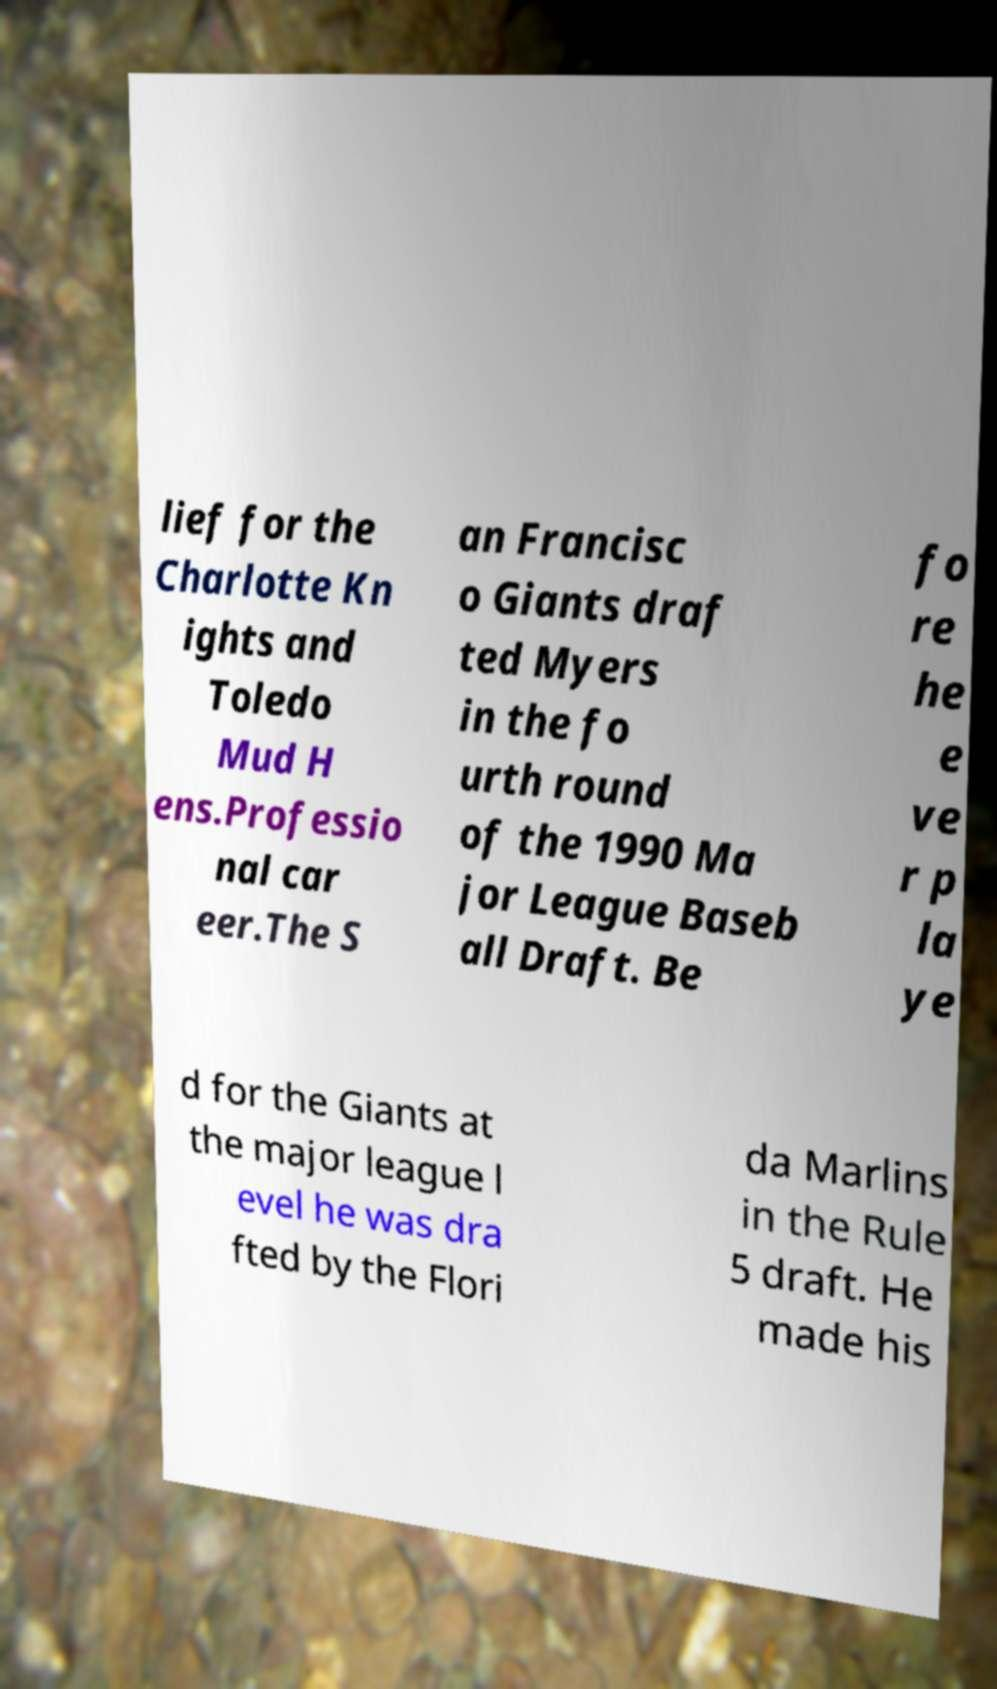What messages or text are displayed in this image? I need them in a readable, typed format. lief for the Charlotte Kn ights and Toledo Mud H ens.Professio nal car eer.The S an Francisc o Giants draf ted Myers in the fo urth round of the 1990 Ma jor League Baseb all Draft. Be fo re he e ve r p la ye d for the Giants at the major league l evel he was dra fted by the Flori da Marlins in the Rule 5 draft. He made his 